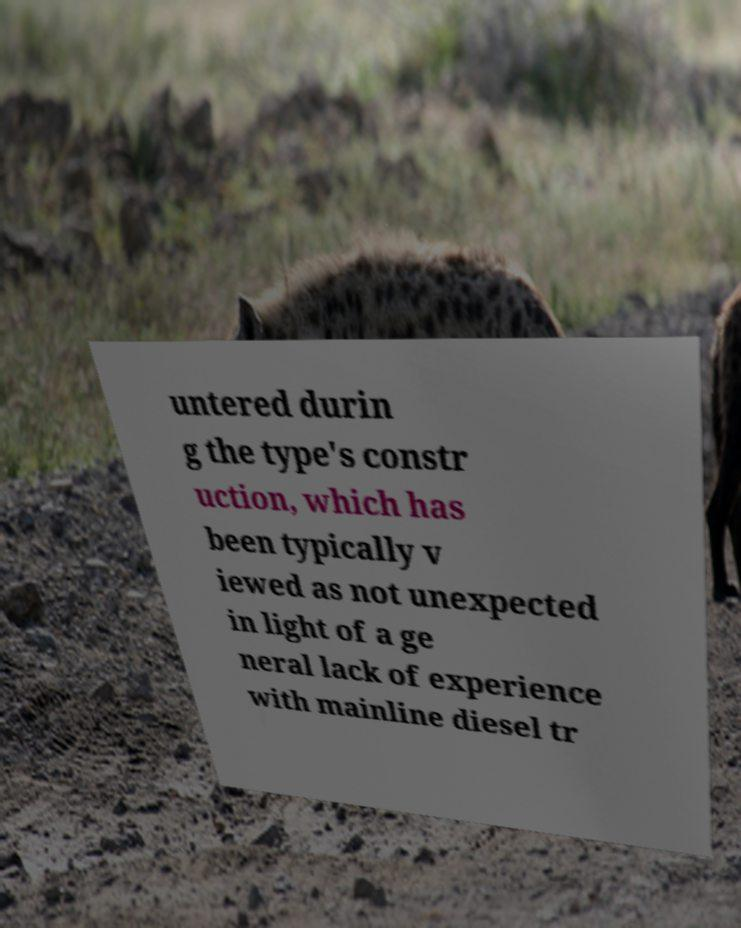Can you read and provide the text displayed in the image?This photo seems to have some interesting text. Can you extract and type it out for me? untered durin g the type's constr uction, which has been typically v iewed as not unexpected in light of a ge neral lack of experience with mainline diesel tr 